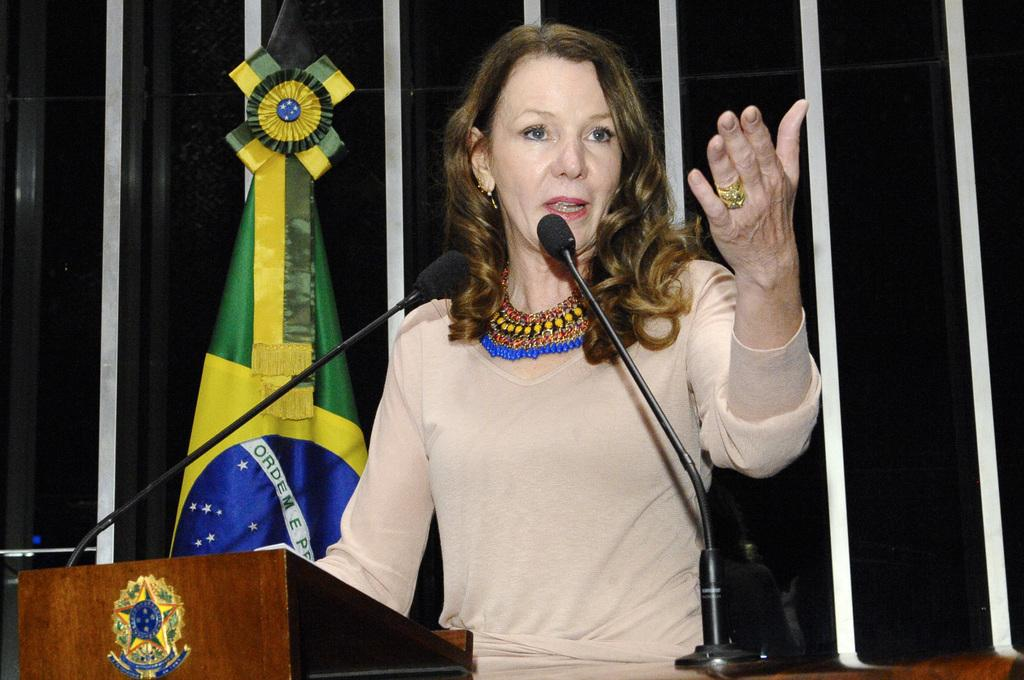Who is the main subject in the image? There is a person in the image. What is the person doing in the image? The person is talking into a microphone. What object is in front of the person? There is a podium in front of the person. What can be seen in the background of the image? There is a flag visible in the image. What type of clouds can be seen in the image? There are no clouds visible in the image. How many cars are parked near the person in the image? There are no cars present in the image. 